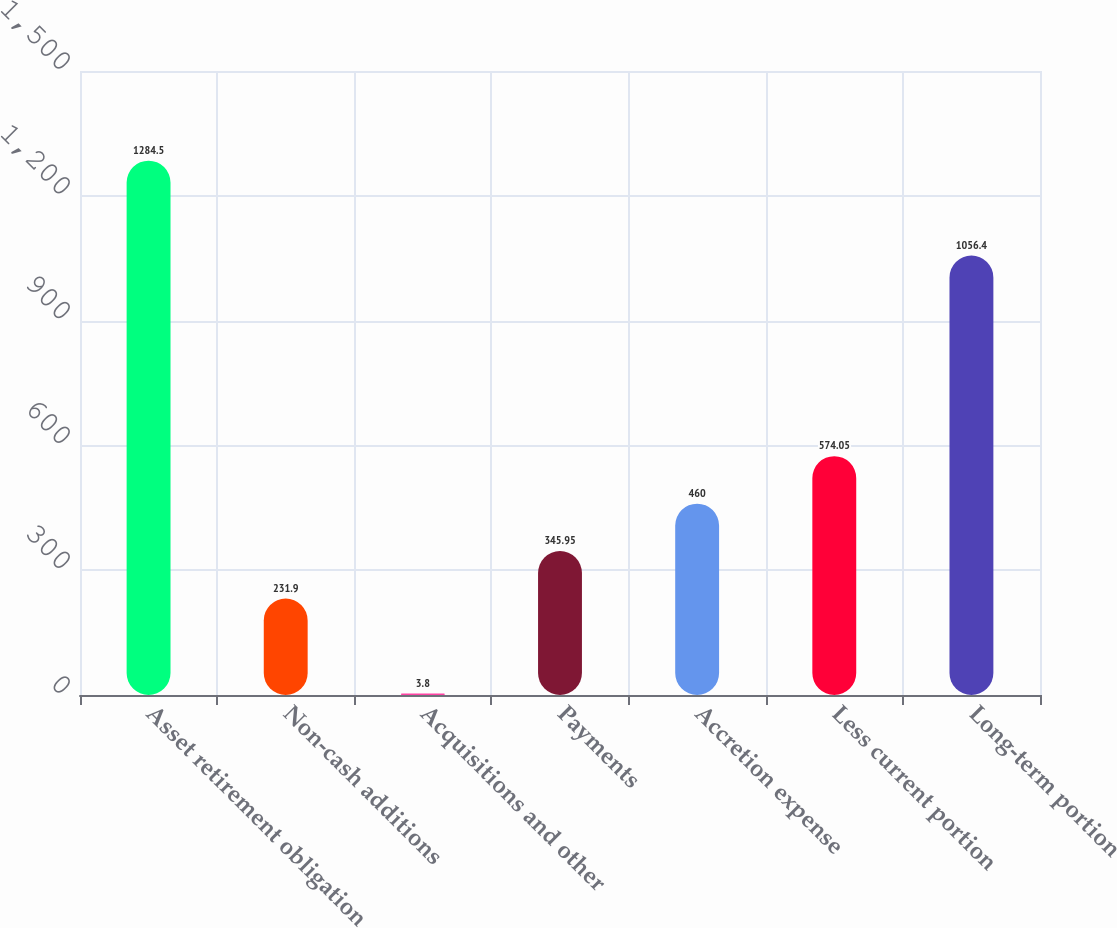Convert chart to OTSL. <chart><loc_0><loc_0><loc_500><loc_500><bar_chart><fcel>Asset retirement obligation<fcel>Non-cash additions<fcel>Acquisitions and other<fcel>Payments<fcel>Accretion expense<fcel>Less current portion<fcel>Long-term portion<nl><fcel>1284.5<fcel>231.9<fcel>3.8<fcel>345.95<fcel>460<fcel>574.05<fcel>1056.4<nl></chart> 